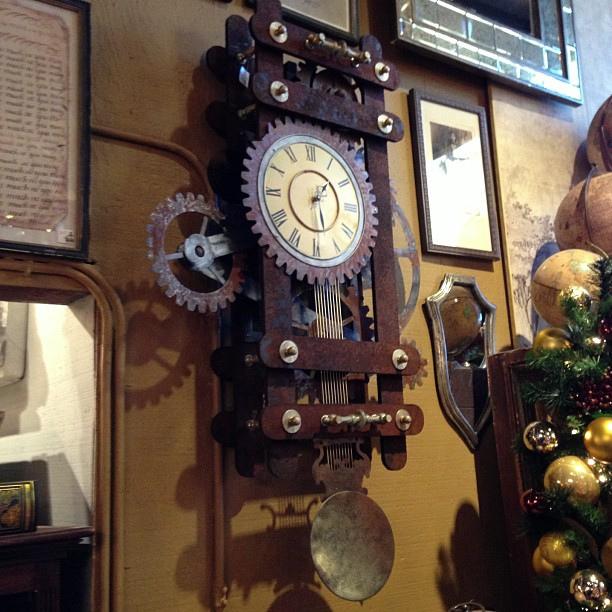What color is the clock?
Quick response, please. Brown. Is that a small clock?
Concise answer only. Yes. Is there a mirror in the picture?
Quick response, please. Yes. What time does the clock say?
Be succinct. 1:28. How many clocks are on the wall?
Give a very brief answer. 1. What time is on the clock?
Be succinct. 1:30. What holiday was this picture probably taken around?
Answer briefly. Christmas. 